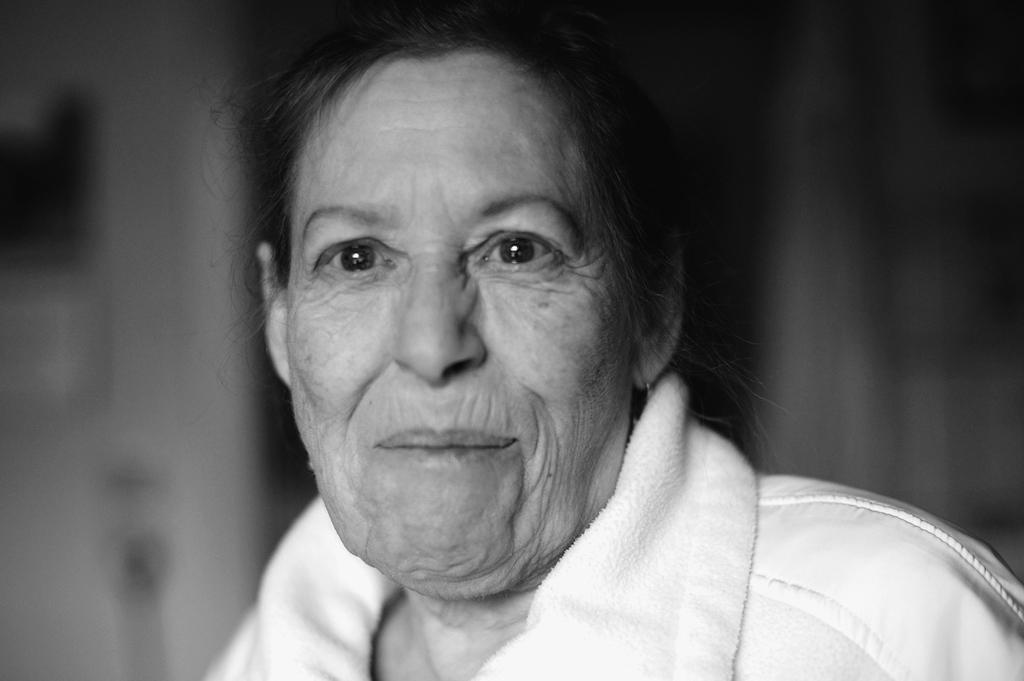Who is the main subject in the image? There is an old lady in the image. What is the old lady wearing? The old lady is wearing a white dress. How many pieces of paper are on the ground near the old lady? There is no information about any paper on the ground near the old lady in the provided facts. 